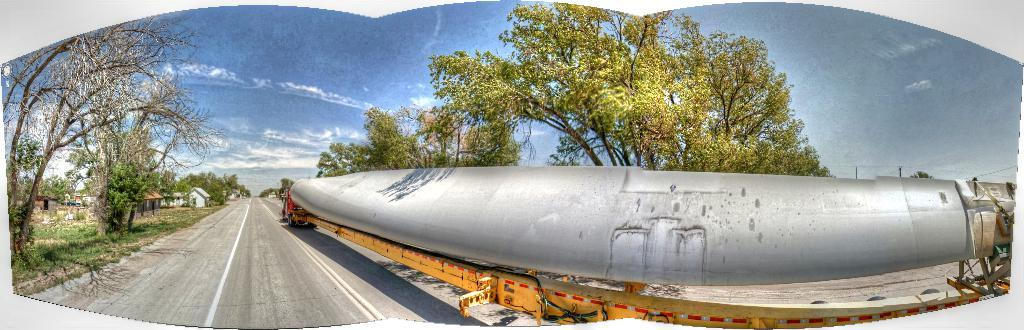What is the main subject of the image? There is a vehicle in the image. What is the vehicle situated on? There is a road in the image. What type of natural elements can be seen in the image? There are trees in the image. What can be seen in the background of the image? There are houses and the sky visible in the background of the image. What type of vegetable is being harvested in the image? There is no vegetable being harvested in the image; it features a vehicle on a road with trees and houses in the background. What record is being played in the image? There is no record being played in the image; it focuses on a vehicle, a road, trees, houses, and the sky. 